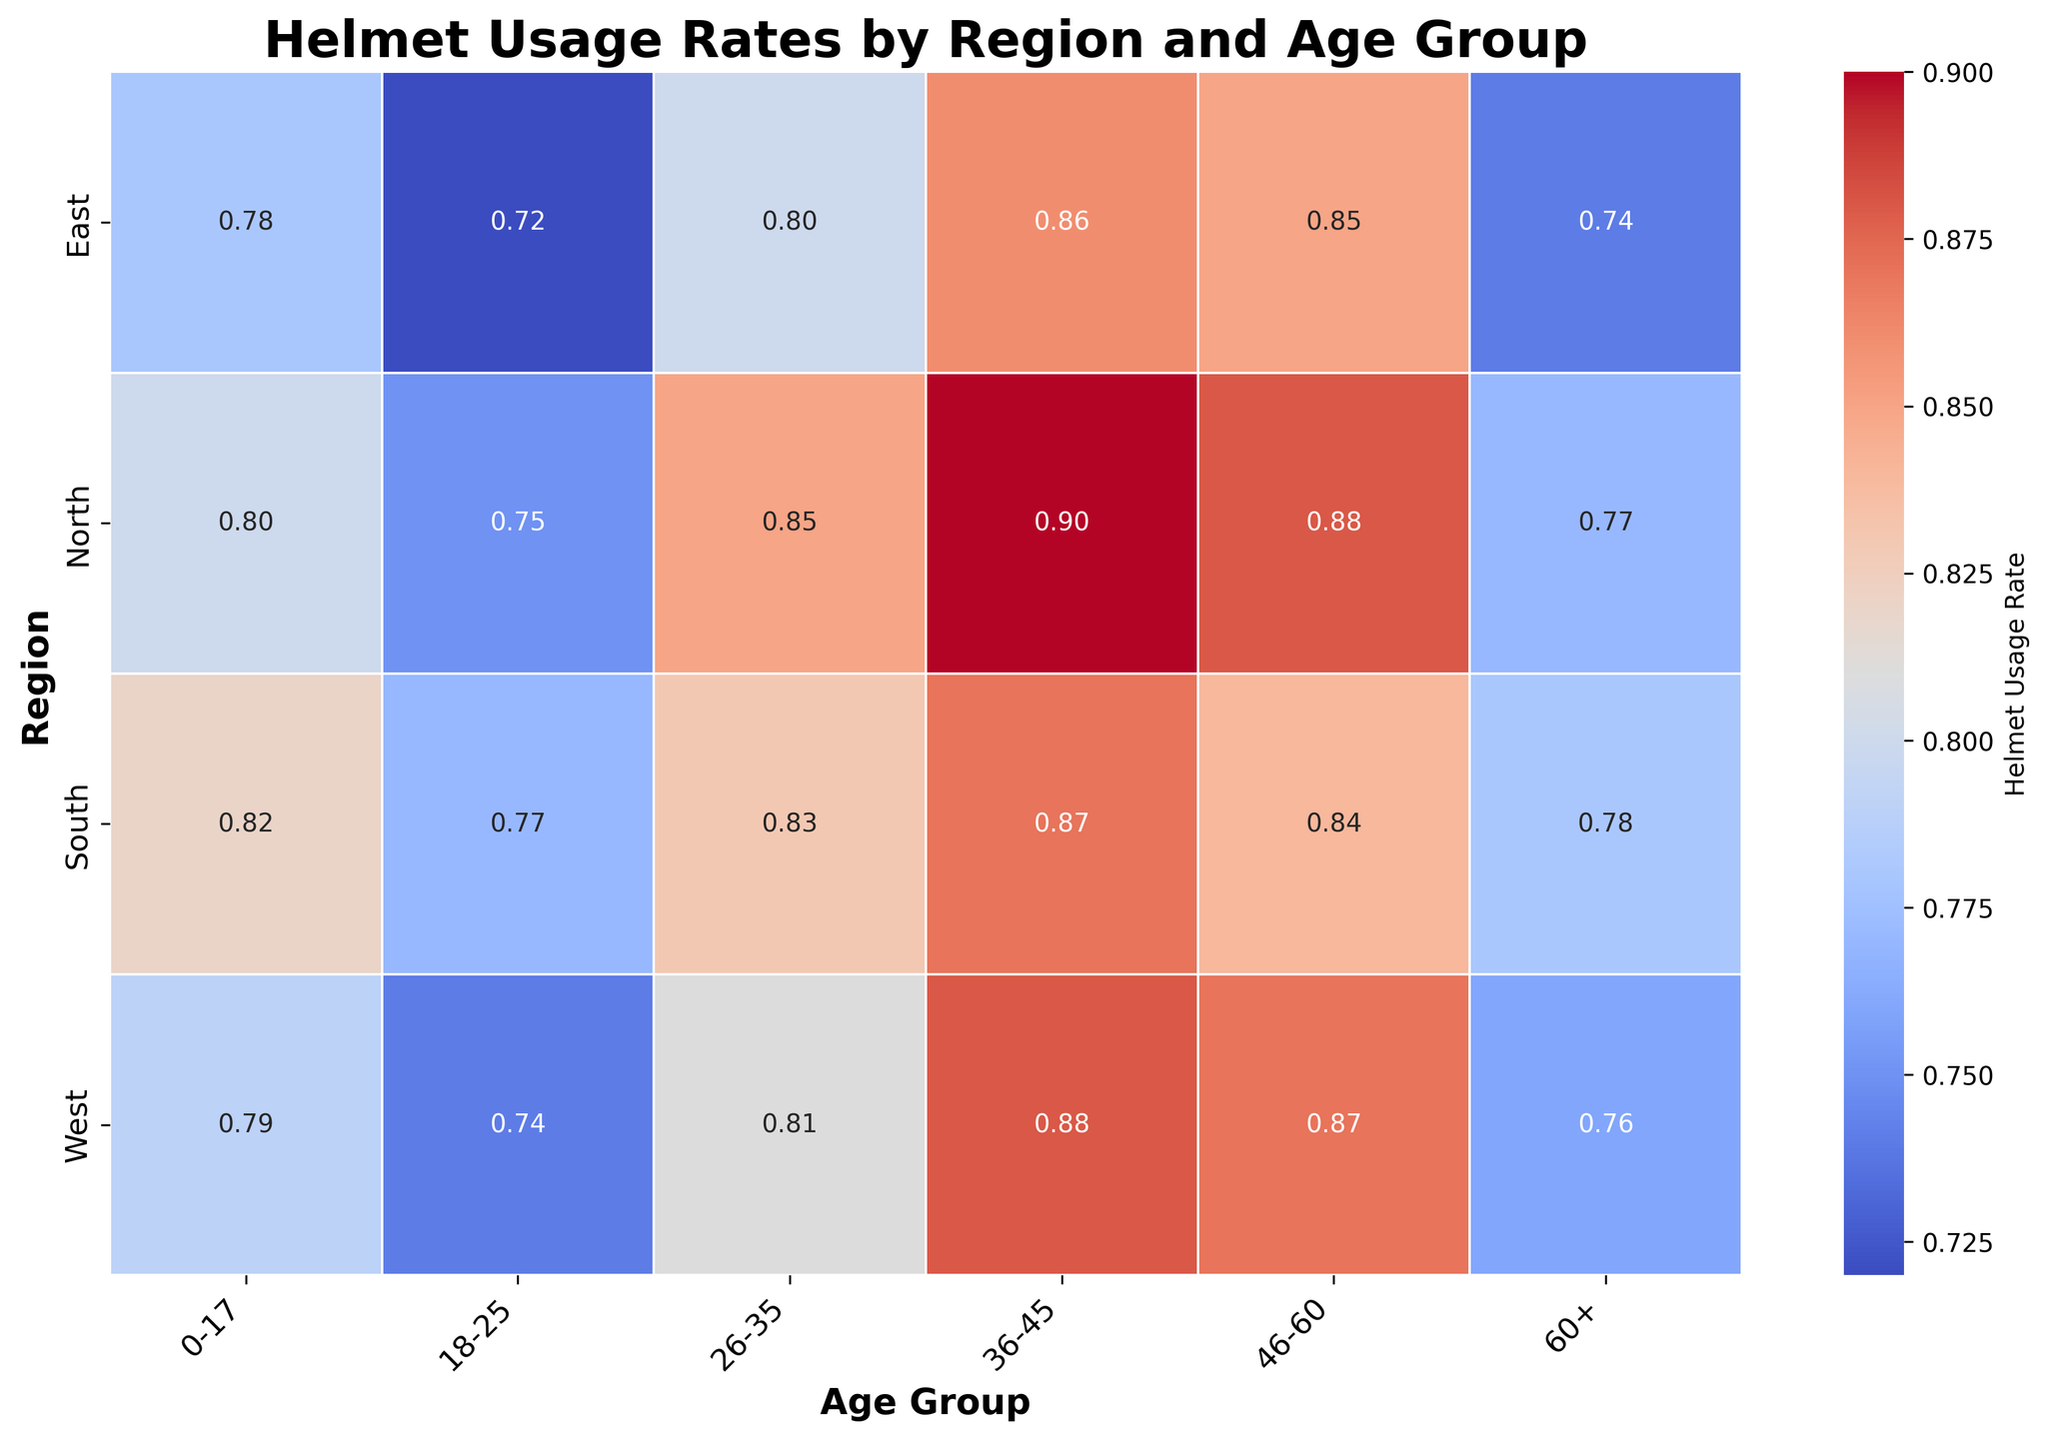Which region has the highest helmet usage rate for the 36-45 age group? By looking at the figure, find the intersection of the "36-45" column and each region. The region with the highest number in this intersection is the one with the highest helmet usage rate for this age group.
Answer: North Which age group in the East shows the lowest helmet usage rate? Find the "East" row in the figure and compare the numbers in that row. The age group with the smallest number is the one with the lowest helmet usage rate.
Answer: 60+ What is the difference in helmet usage rates between the North and South regions for the 18-25 age group? Identify the helmet usage rates for the North and South regions in the "18-25" column. Subtract the value for South from the value for North.
Answer: 0.75 - 0.77 = -0.02 Which age group displays the most consistent helmet usage rate across all regions? Compare the variability of helmet usage rates across regions for each age group. The age group with the smallest range between the highest and lowest values is the most consistent.
Answer: 60+ What is the average helmet usage rate for the 26-35 age group across all regions? Sum the helmet usage rates for the "26-35" age group from each region and then divide by the number of regions (4).
Answer: (0.85 + 0.83 + 0.80 + 0.81) / 4 = 0.8225 Which region shows the largest improvement in helmet usage rate from the 18-25 to the 36-45 age group? Calculate the difference between the helmet usage rates for the 18-25 and 36-45 age groups for each region. The region with the largest positive difference has the greatest improvement.
Answer: North Which region has the lowest helmet usage rate overall, and which age group contributes most to this low rate? Calculate the average helmet usage rates across all age groups for each region. Then identify the lowest average rate and the age group within that region that has the lowest individual rate.
Answer: East, 18-25 